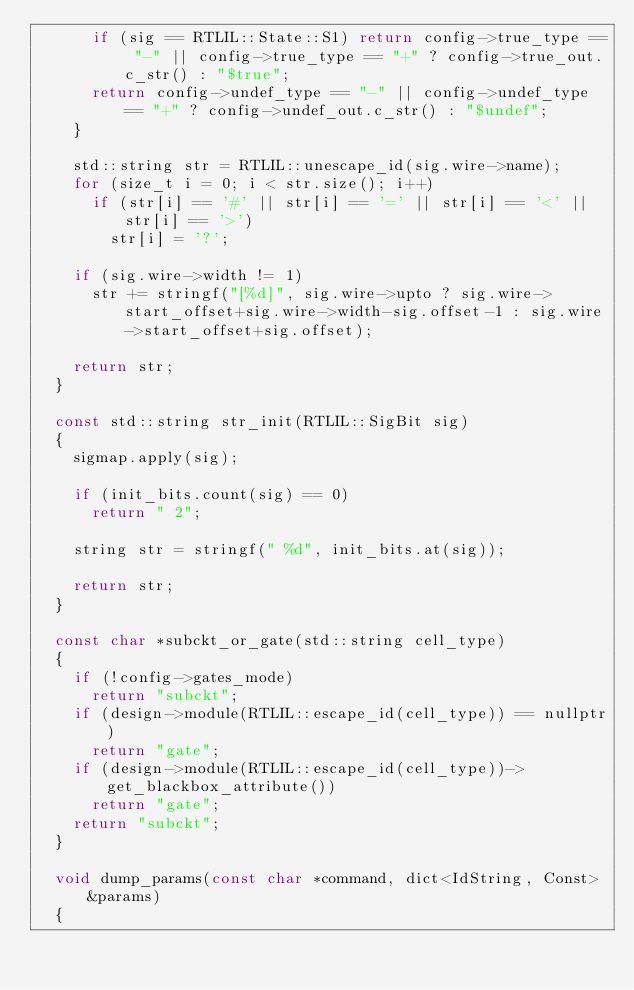<code> <loc_0><loc_0><loc_500><loc_500><_C++_>			if (sig == RTLIL::State::S1) return config->true_type == "-" || config->true_type == "+" ? config->true_out.c_str() : "$true";
			return config->undef_type == "-" || config->undef_type == "+" ? config->undef_out.c_str() : "$undef";
		}

		std::string str = RTLIL::unescape_id(sig.wire->name);
		for (size_t i = 0; i < str.size(); i++)
			if (str[i] == '#' || str[i] == '=' || str[i] == '<' || str[i] == '>')
				str[i] = '?';

		if (sig.wire->width != 1)
			str += stringf("[%d]", sig.wire->upto ? sig.wire->start_offset+sig.wire->width-sig.offset-1 : sig.wire->start_offset+sig.offset);

		return str;
	}

	const std::string str_init(RTLIL::SigBit sig)
	{
		sigmap.apply(sig);

		if (init_bits.count(sig) == 0)
			return " 2";

		string str = stringf(" %d", init_bits.at(sig));

		return str;
	}

	const char *subckt_or_gate(std::string cell_type)
	{
		if (!config->gates_mode)
			return "subckt";
		if (design->module(RTLIL::escape_id(cell_type)) == nullptr)
			return "gate";
		if (design->module(RTLIL::escape_id(cell_type))->get_blackbox_attribute())
			return "gate";
		return "subckt";
	}

	void dump_params(const char *command, dict<IdString, Const> &params)
	{</code> 